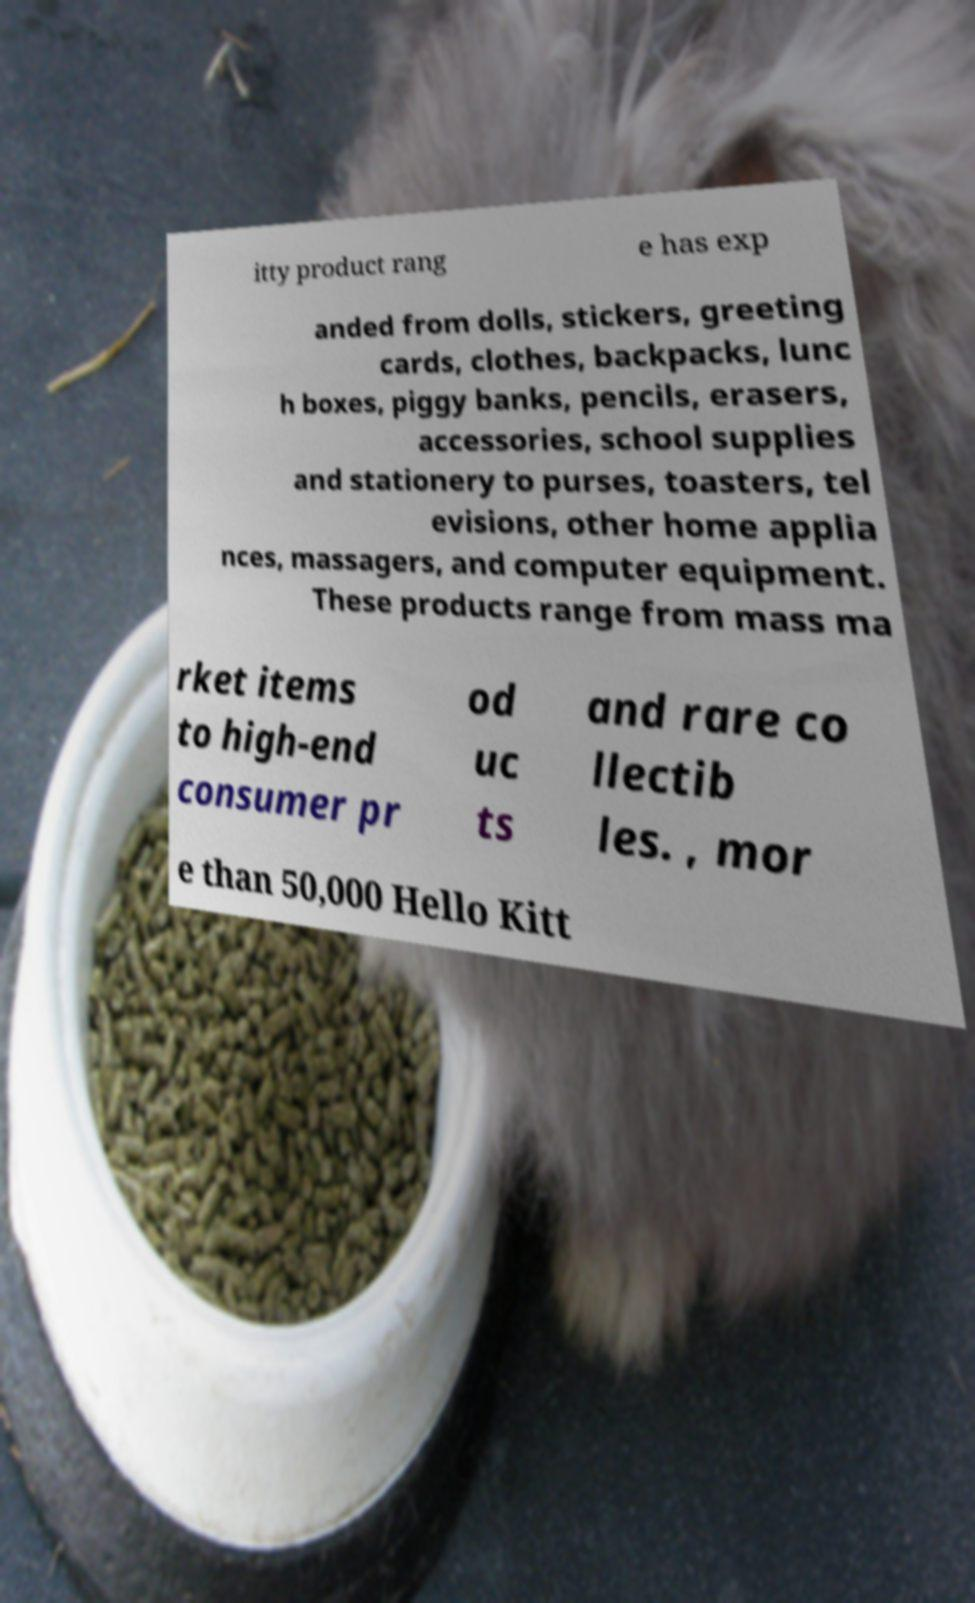What messages or text are displayed in this image? I need them in a readable, typed format. itty product rang e has exp anded from dolls, stickers, greeting cards, clothes, backpacks, lunc h boxes, piggy banks, pencils, erasers, accessories, school supplies and stationery to purses, toasters, tel evisions, other home applia nces, massagers, and computer equipment. These products range from mass ma rket items to high-end consumer pr od uc ts and rare co llectib les. , mor e than 50,000 Hello Kitt 